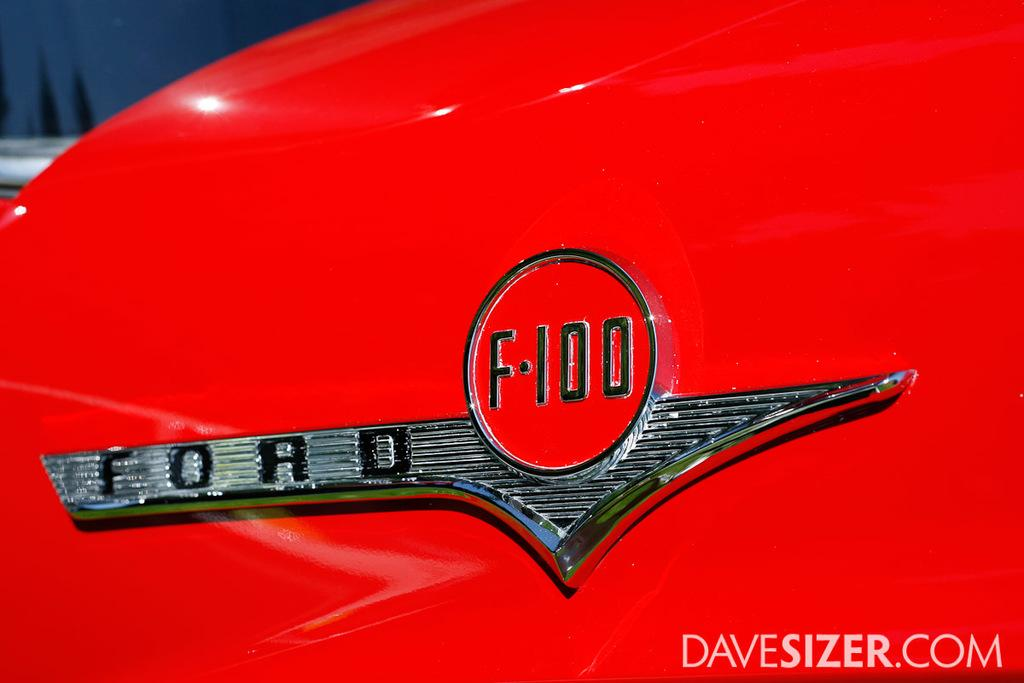What is the color of the object in the image? The object in the image has a red color. What is featured on the object? There is a logo on the object. What can be seen at the bottom of the image? There is text written at the bottom of the image. How would you describe the background of the image? The background of the image is blurred. Can you see a tent in the image? There is no tent present in the image. What type of potato is shown in the image? There is no potato present in the image. 